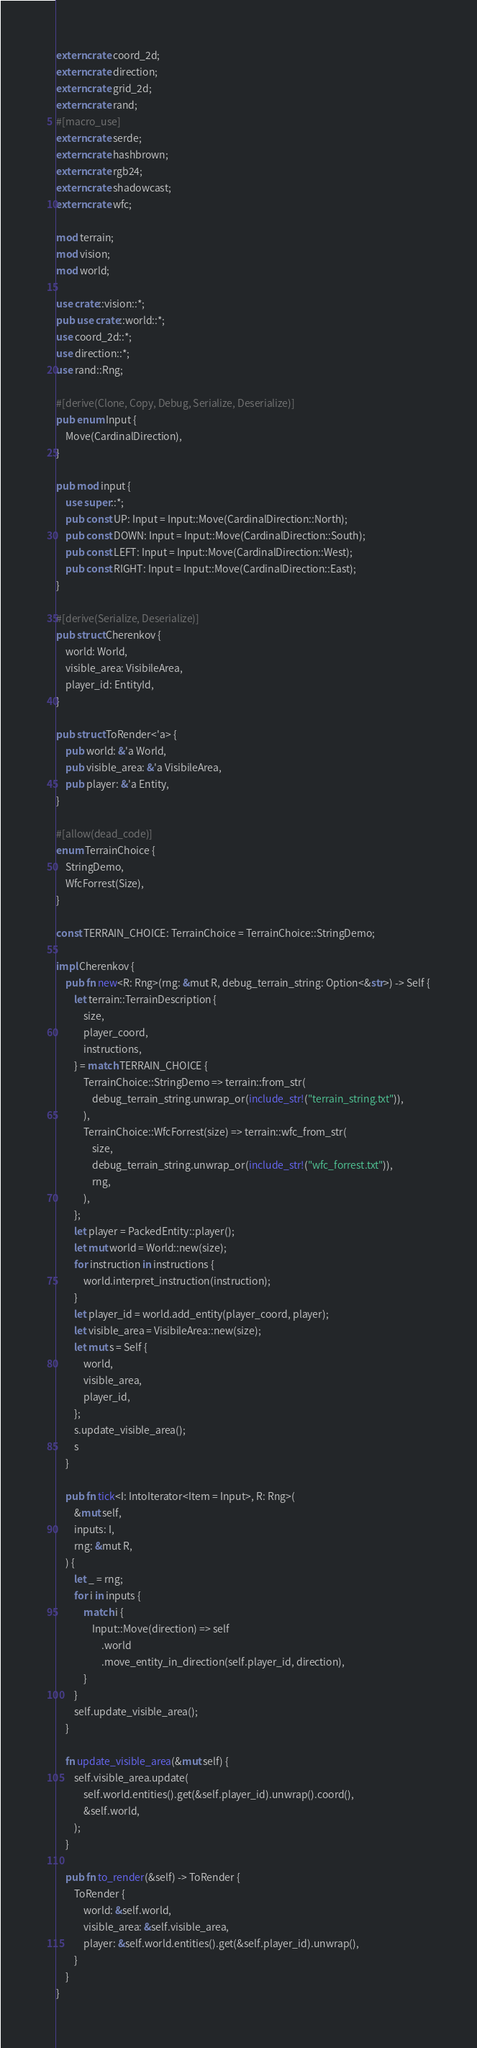<code> <loc_0><loc_0><loc_500><loc_500><_Rust_>extern crate coord_2d;
extern crate direction;
extern crate grid_2d;
extern crate rand;
#[macro_use]
extern crate serde;
extern crate hashbrown;
extern crate rgb24;
extern crate shadowcast;
extern crate wfc;

mod terrain;
mod vision;
mod world;

use crate::vision::*;
pub use crate::world::*;
use coord_2d::*;
use direction::*;
use rand::Rng;

#[derive(Clone, Copy, Debug, Serialize, Deserialize)]
pub enum Input {
    Move(CardinalDirection),
}

pub mod input {
    use super::*;
    pub const UP: Input = Input::Move(CardinalDirection::North);
    pub const DOWN: Input = Input::Move(CardinalDirection::South);
    pub const LEFT: Input = Input::Move(CardinalDirection::West);
    pub const RIGHT: Input = Input::Move(CardinalDirection::East);
}

#[derive(Serialize, Deserialize)]
pub struct Cherenkov {
    world: World,
    visible_area: VisibileArea,
    player_id: EntityId,
}

pub struct ToRender<'a> {
    pub world: &'a World,
    pub visible_area: &'a VisibileArea,
    pub player: &'a Entity,
}

#[allow(dead_code)]
enum TerrainChoice {
    StringDemo,
    WfcForrest(Size),
}

const TERRAIN_CHOICE: TerrainChoice = TerrainChoice::StringDemo;

impl Cherenkov {
    pub fn new<R: Rng>(rng: &mut R, debug_terrain_string: Option<&str>) -> Self {
        let terrain::TerrainDescription {
            size,
            player_coord,
            instructions,
        } = match TERRAIN_CHOICE {
            TerrainChoice::StringDemo => terrain::from_str(
                debug_terrain_string.unwrap_or(include_str!("terrain_string.txt")),
            ),
            TerrainChoice::WfcForrest(size) => terrain::wfc_from_str(
                size,
                debug_terrain_string.unwrap_or(include_str!("wfc_forrest.txt")),
                rng,
            ),
        };
        let player = PackedEntity::player();
        let mut world = World::new(size);
        for instruction in instructions {
            world.interpret_instruction(instruction);
        }
        let player_id = world.add_entity(player_coord, player);
        let visible_area = VisibileArea::new(size);
        let mut s = Self {
            world,
            visible_area,
            player_id,
        };
        s.update_visible_area();
        s
    }

    pub fn tick<I: IntoIterator<Item = Input>, R: Rng>(
        &mut self,
        inputs: I,
        rng: &mut R,
    ) {
        let _ = rng;
        for i in inputs {
            match i {
                Input::Move(direction) => self
                    .world
                    .move_entity_in_direction(self.player_id, direction),
            }
        }
        self.update_visible_area();
    }

    fn update_visible_area(&mut self) {
        self.visible_area.update(
            self.world.entities().get(&self.player_id).unwrap().coord(),
            &self.world,
        );
    }

    pub fn to_render(&self) -> ToRender {
        ToRender {
            world: &self.world,
            visible_area: &self.visible_area,
            player: &self.world.entities().get(&self.player_id).unwrap(),
        }
    }
}
</code> 